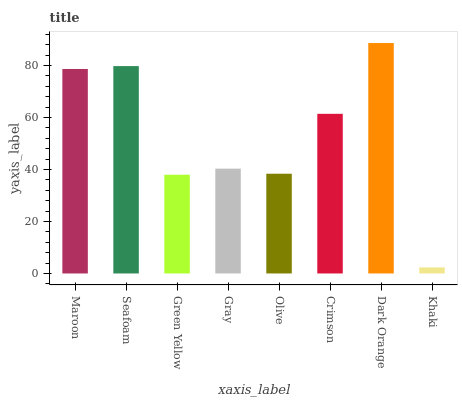Is Khaki the minimum?
Answer yes or no. Yes. Is Dark Orange the maximum?
Answer yes or no. Yes. Is Seafoam the minimum?
Answer yes or no. No. Is Seafoam the maximum?
Answer yes or no. No. Is Seafoam greater than Maroon?
Answer yes or no. Yes. Is Maroon less than Seafoam?
Answer yes or no. Yes. Is Maroon greater than Seafoam?
Answer yes or no. No. Is Seafoam less than Maroon?
Answer yes or no. No. Is Crimson the high median?
Answer yes or no. Yes. Is Gray the low median?
Answer yes or no. Yes. Is Khaki the high median?
Answer yes or no. No. Is Green Yellow the low median?
Answer yes or no. No. 